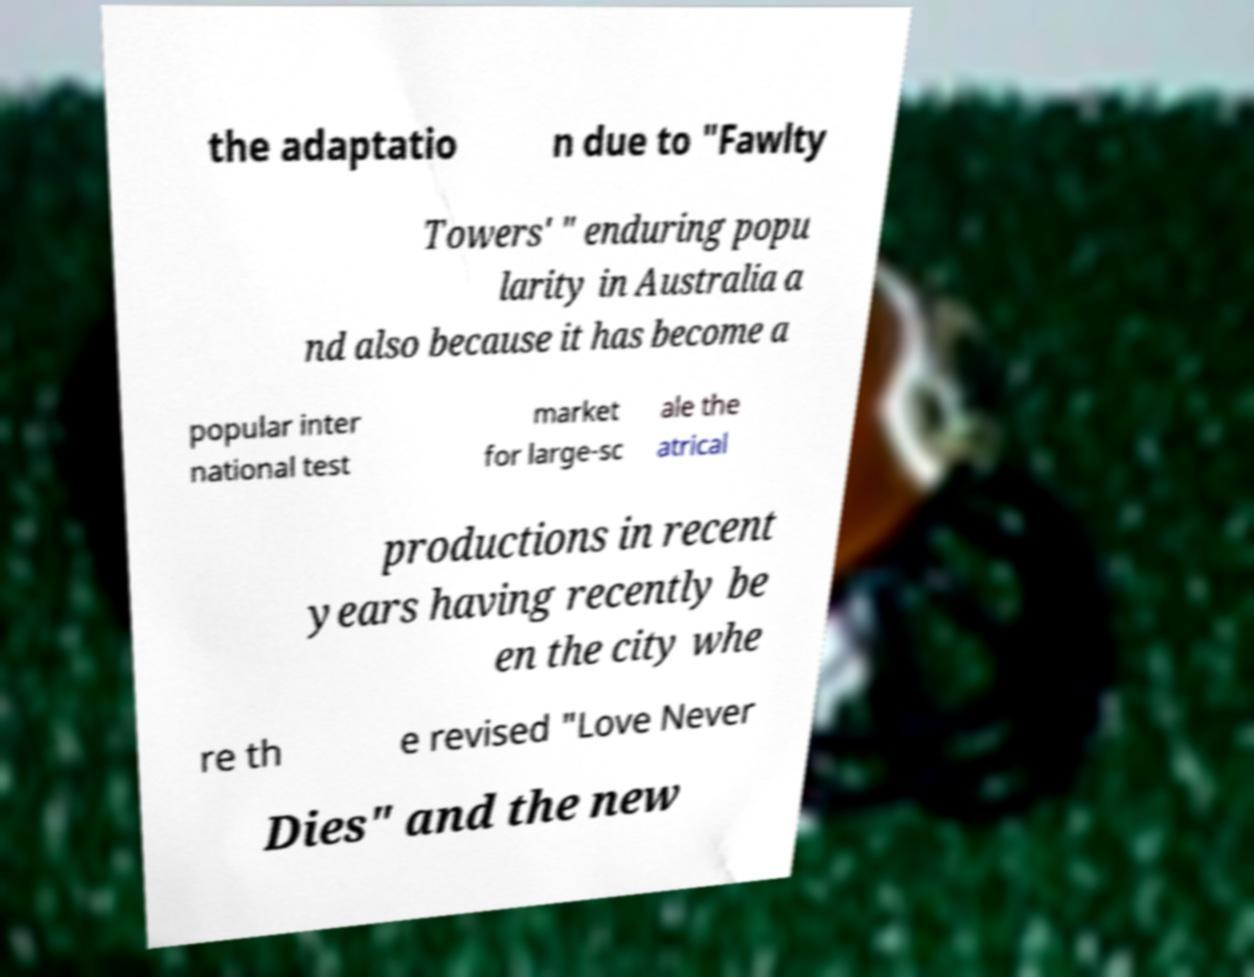What messages or text are displayed in this image? I need them in a readable, typed format. the adaptatio n due to "Fawlty Towers' " enduring popu larity in Australia a nd also because it has become a popular inter national test market for large-sc ale the atrical productions in recent years having recently be en the city whe re th e revised "Love Never Dies" and the new 